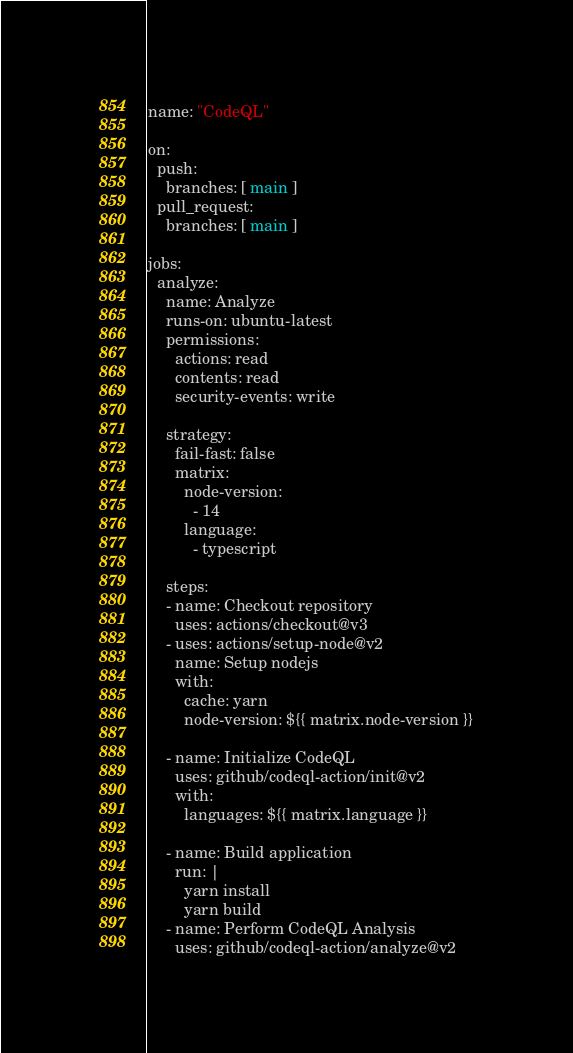<code> <loc_0><loc_0><loc_500><loc_500><_YAML_>name: "CodeQL"

on:
  push:
    branches: [ main ]
  pull_request:
    branches: [ main ]

jobs:
  analyze:
    name: Analyze
    runs-on: ubuntu-latest
    permissions:
      actions: read
      contents: read
      security-events: write

    strategy:
      fail-fast: false
      matrix:
        node-version:
          - 14
        language:
          - typescript

    steps:
    - name: Checkout repository
      uses: actions/checkout@v3
    - uses: actions/setup-node@v2
      name: Setup nodejs
      with:
        cache: yarn
        node-version: ${{ matrix.node-version }}

    - name: Initialize CodeQL
      uses: github/codeql-action/init@v2
      with:
        languages: ${{ matrix.language }}
        
    - name: Build application
      run: |
        yarn install
        yarn build
    - name: Perform CodeQL Analysis
      uses: github/codeql-action/analyze@v2
</code> 